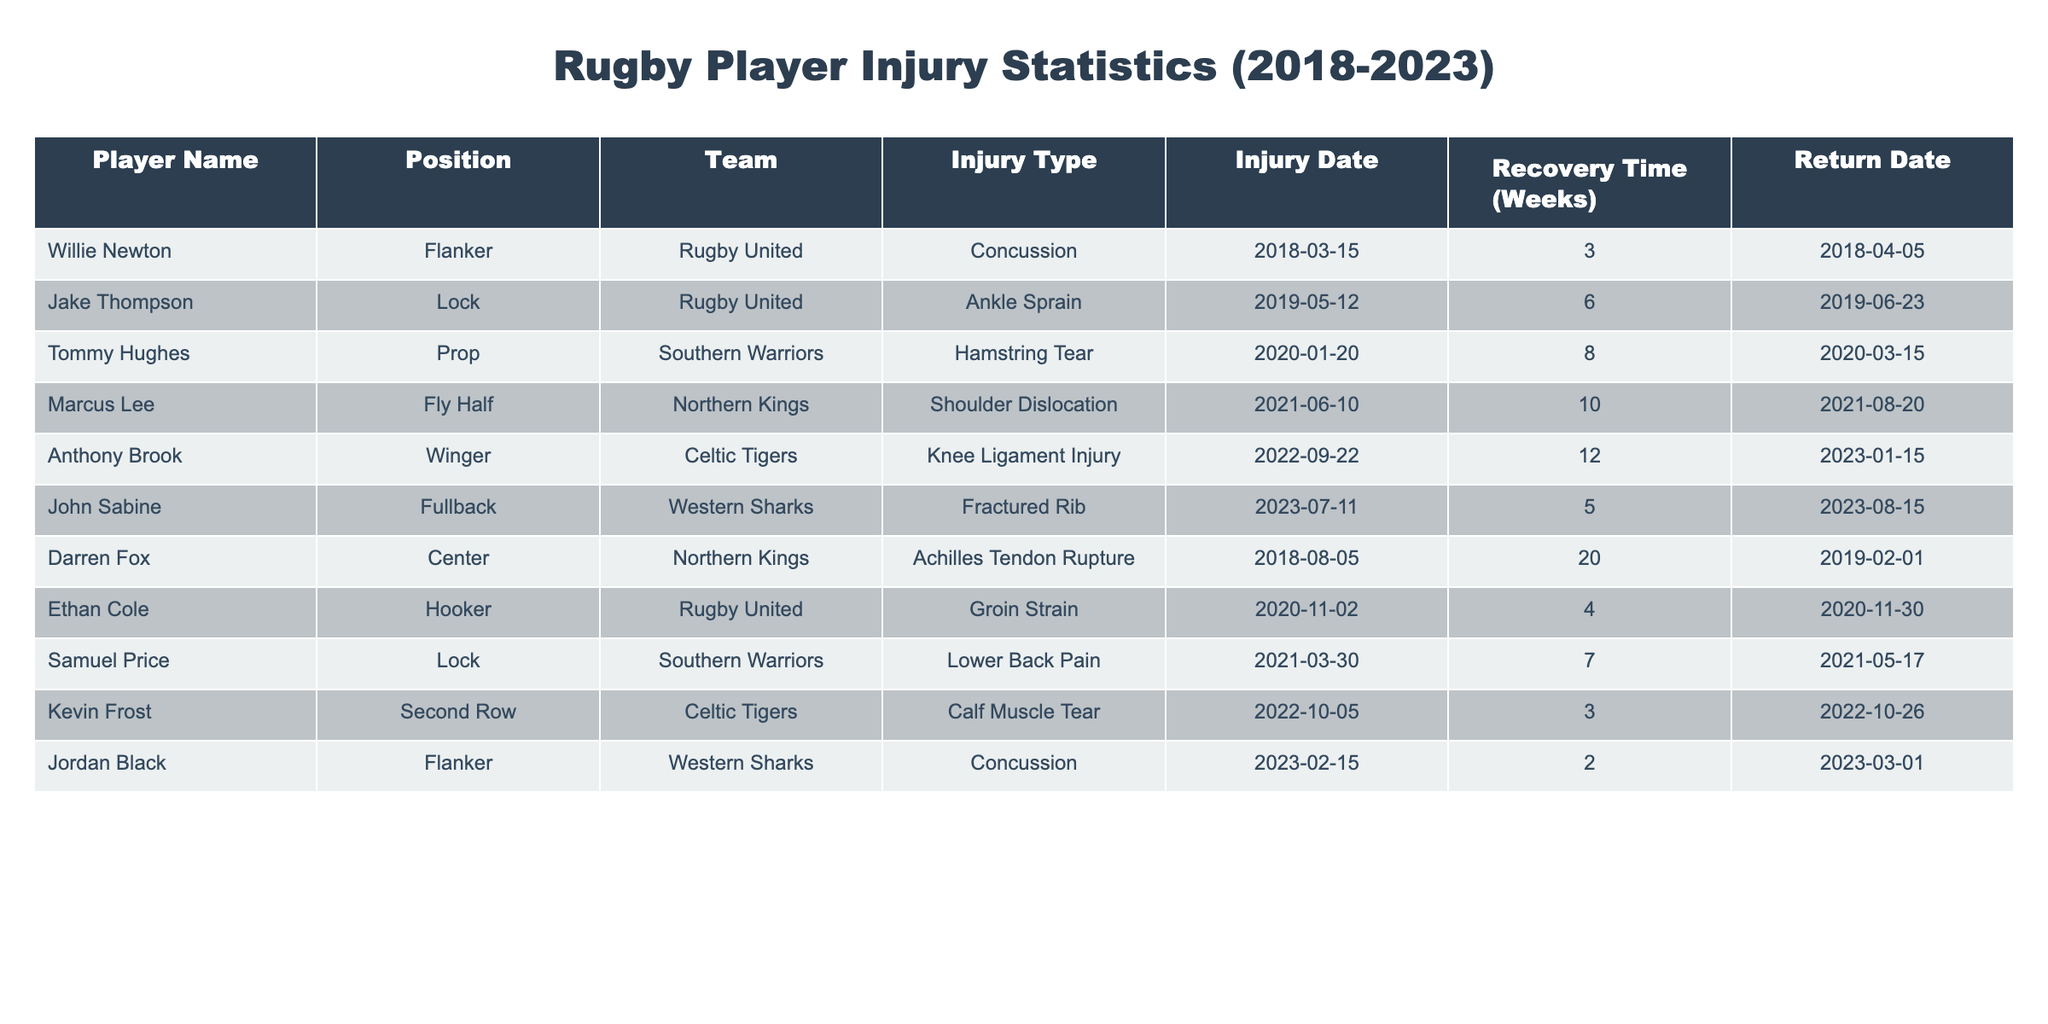What is the recovery time for Willie Newton? According to the table, Willie Newton's recovery time is listed as 3 weeks.
Answer: 3 weeks Which player suffered an Achilles tendon rupture? The table indicates that Darren Fox is the player who suffered an Achilles tendon rupture.
Answer: Darren Fox How many weeks did Marcus Lee take to recover from his injury? The table states that Marcus Lee took 10 weeks to recover from his shoulder dislocation.
Answer: 10 weeks Are there any players who returned within 4 weeks after their injury? By examining the return dates and recovery times, both Ethan Cole and Jordan Black returned within 4 weeks after their injuries.
Answer: Yes What is the average recovery time for injuries in this table? To find the average recovery time, sum the recovery times: 3 + 6 + 8 + 10 + 12 + 5 + 20 + 4 + 7 + 3 + 2 =  76 weeks. There are 11 entries, so the average is 76/11 ≈ 6.91 weeks.
Answer: Approximately 6.91 weeks How many players returned from their injuries by the end of 2023? Analyzing the table, we see that Anthony Brook, John Sabine, and Jordan Black returned by the end of 2023. There are 3 players who fit this criterion.
Answer: 3 players Is it true that all injuries recorded in the table occurred in the last five years? Upon reviewing the injury dates in the table, all injuries took place from 2018 to 2023, which is within the last five years.
Answer: Yes Which player had the longest recovery time? By examining the recovery times, Darren Fox had the longest recovery time of 20 weeks due to an Achilles tendon rupture.
Answer: Darren Fox What was the injury type of the player returning on 2023-01-15? Looking at the return date of 2023-01-15, Anthony Brook is the player who returned on this date, and he suffered a knee ligament injury.
Answer: Knee ligament injury 